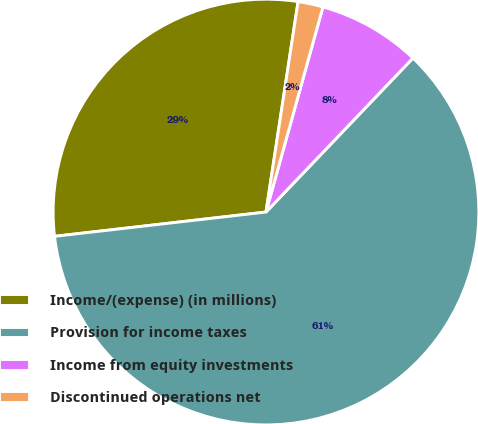<chart> <loc_0><loc_0><loc_500><loc_500><pie_chart><fcel>Income/(expense) (in millions)<fcel>Provision for income taxes<fcel>Income from equity investments<fcel>Discontinued operations net<nl><fcel>29.23%<fcel>61.05%<fcel>7.82%<fcel>1.9%<nl></chart> 